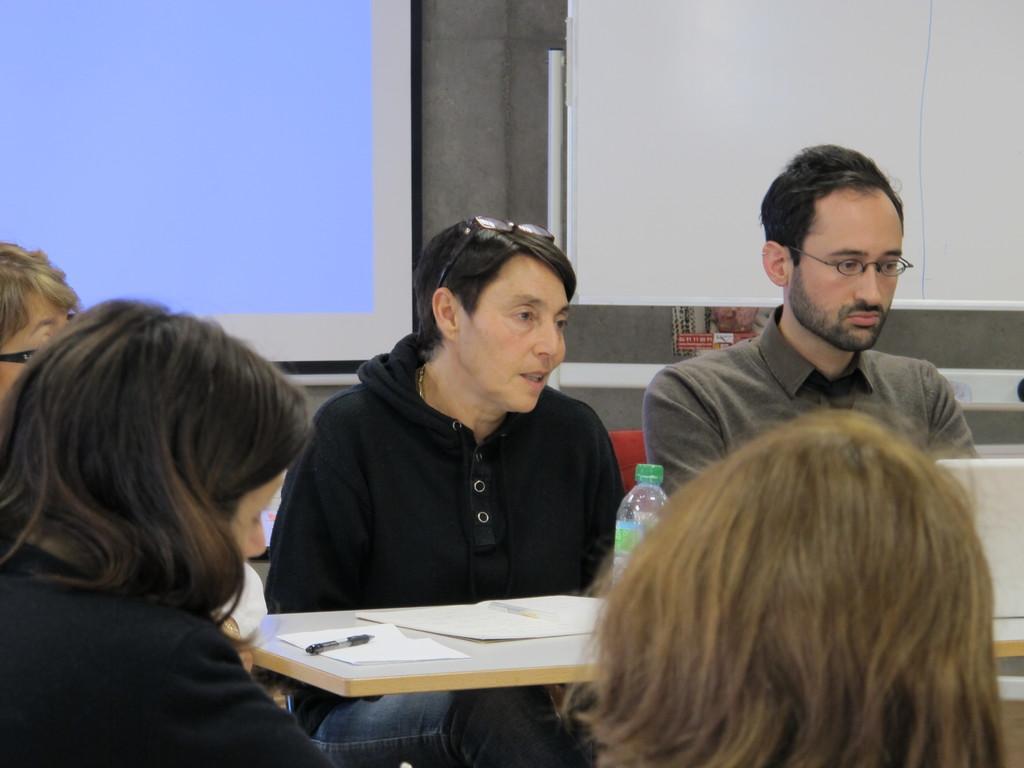Describe this image in one or two sentences. In this image I see 5 persons and there is a table in front of them. On the table I see few papers, a pen and the bottle. In the background I see the screen and the wall. 